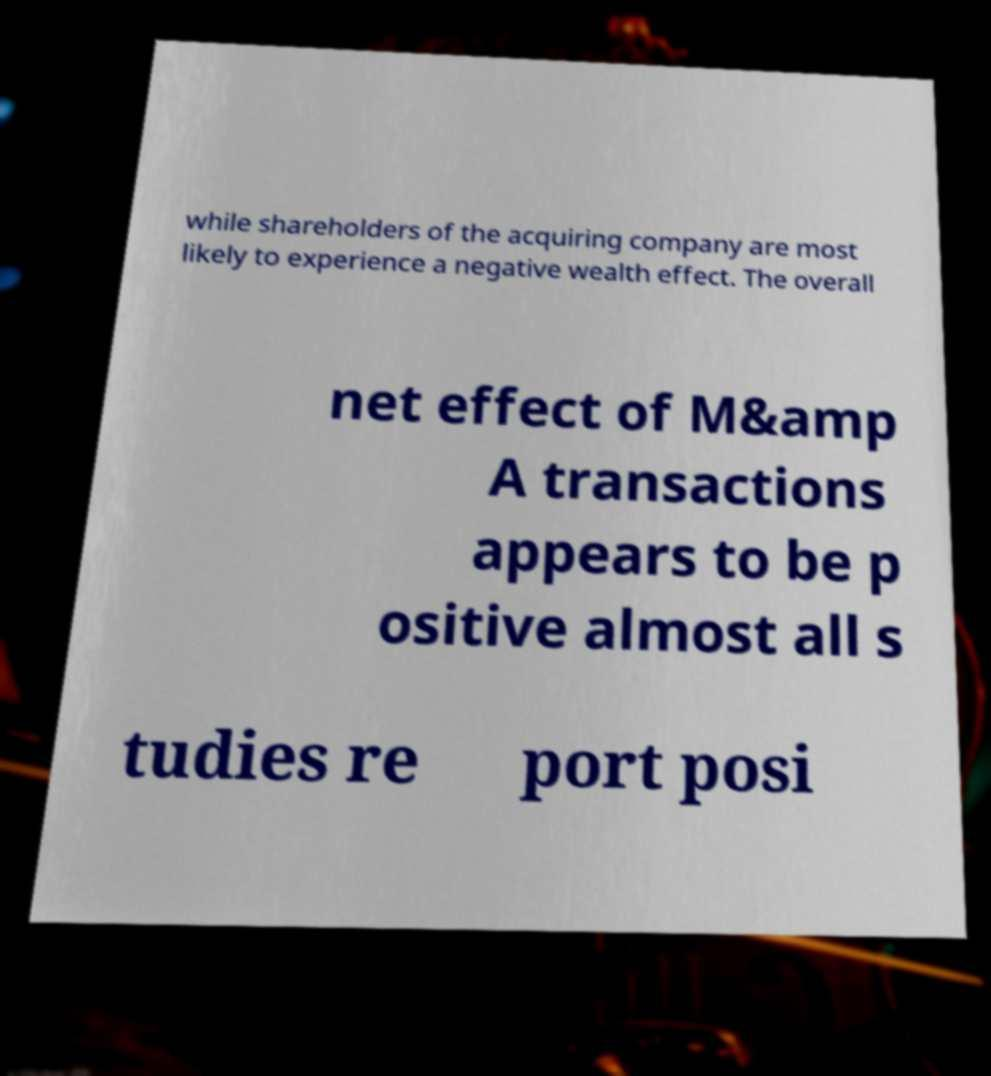What messages or text are displayed in this image? I need them in a readable, typed format. while shareholders of the acquiring company are most likely to experience a negative wealth effect. The overall net effect of M&amp A transactions appears to be p ositive almost all s tudies re port posi 